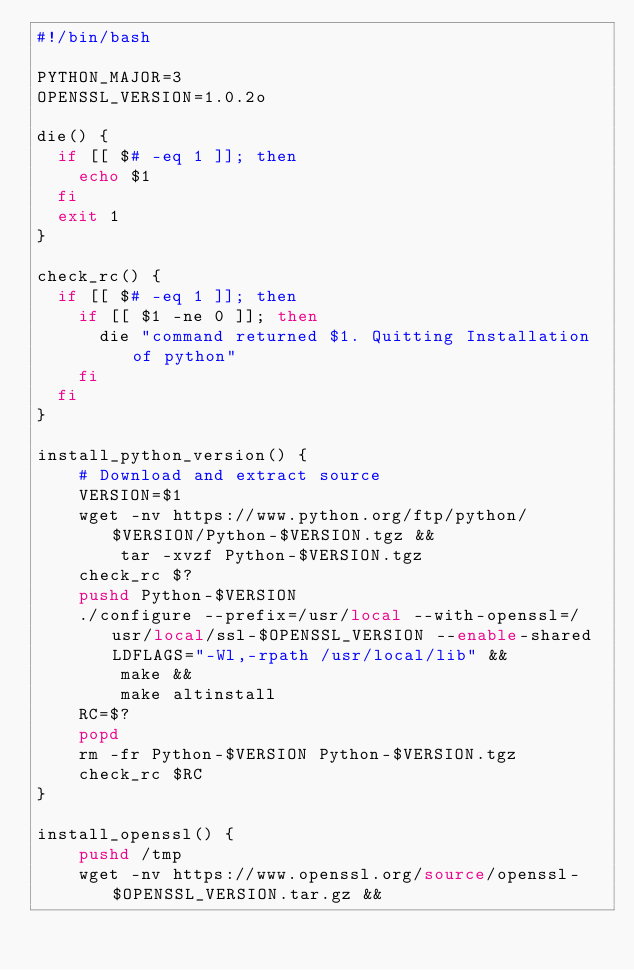Convert code to text. <code><loc_0><loc_0><loc_500><loc_500><_Bash_>#!/bin/bash

PYTHON_MAJOR=3
OPENSSL_VERSION=1.0.2o

die() {
  if [[ $# -eq 1 ]]; then
    echo $1
  fi
  exit 1
}

check_rc() {
  if [[ $# -eq 1 ]]; then
    if [[ $1 -ne 0 ]]; then
      die "command returned $1. Quitting Installation of python"
    fi
  fi
}

install_python_version() {
	# Download and extract source
	VERSION=$1
	wget -nv https://www.python.org/ftp/python/$VERSION/Python-$VERSION.tgz &&
		tar -xvzf Python-$VERSION.tgz
	check_rc $?
	pushd Python-$VERSION
	./configure --prefix=/usr/local --with-openssl=/usr/local/ssl-$OPENSSL_VERSION --enable-shared LDFLAGS="-Wl,-rpath /usr/local/lib" &&
		make &&
		make altinstall
	RC=$?
	popd
	rm -fr Python-$VERSION Python-$VERSION.tgz
	check_rc $RC
}

install_openssl() {
	pushd /tmp
	wget -nv https://www.openssl.org/source/openssl-$OPENSSL_VERSION.tar.gz &&</code> 